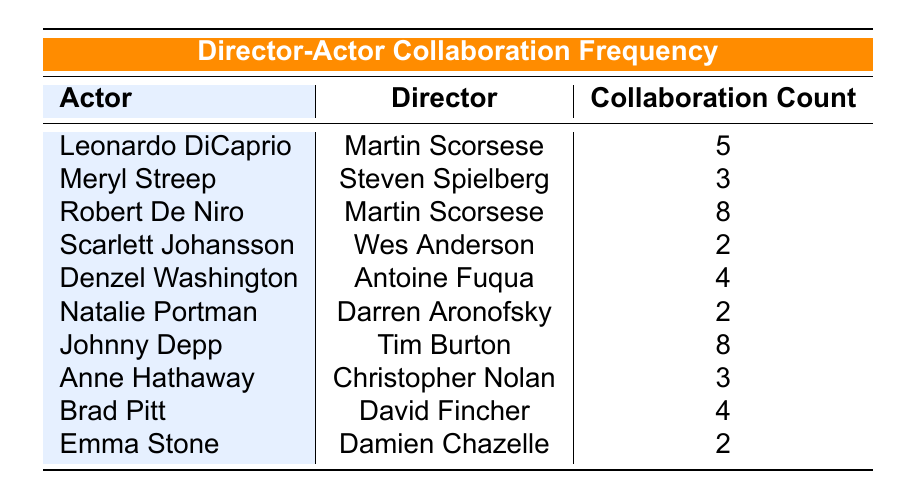What is the highest collaboration count between an actor and a director in the table? The highest collaboration count can be found by looking at the values in the "Collaboration Count" column. The maximum value is 8, which corresponds to Johnny Depp with Tim Burton and Robert De Niro with Martin Scorsese.
Answer: 8 How many collaborations did Robert De Niro have with Martin Scorsese? The table directly lists Robert De Niro's collaboration with Martin Scorsese, which shows a collaboration count of 8.
Answer: 8 Is there any actor who has collaborated with a director more than five times? By reviewing the "Collaboration Count" column, we can see that both Robert De Niro (8) and Johnny Depp (8) have collaborations that exceed five. Hence, the answer is yes.
Answer: Yes What is the average collaboration count for all the actors listed in the table? To find the average, sum all the collaboration counts: (5 + 3 + 8 + 2 + 4 + 2 + 8 + 3 + 4 + 2) = 41, and divide by the number of actors (10), which gives 41/10 = 4.1.
Answer: 4.1 Did any actor collaborate with more than one director? From the table, it appears that each actor is paired with only one director each. Hence, no actor is shown collaborating with multiple directors.
Answer: No How many actors collaborated with their respective directors at least twice? By checking the "Collaboration Count" column, we can see that all actors except Scarlett Johansson, Natalie Portman, and Emma Stone have collaboration counts of 2 or more, totaling 7 actors.
Answer: 7 What is the difference in collaboration counts between the highest (8) and the lowest (2) in the table? The highest collaboration count is 8 (Robert De Niro with Martin Scorsese or Johnny Depp with Tim Burton) and the lowest is 2 (Scarlett Johansson with Wes Anderson, Natalie Portman with Darren Aronofsky, or Emma Stone with Damien Chazelle). The difference is calculated as 8 - 2 = 6.
Answer: 6 Which director has the most collaborations listed in the table? To determine this, we compare the number of collaborations each director has with their respective actors. Martin Scorsese (2 actors) and Tim Burton (1 actor) are the directors with the most collaborations, resulting in a tie.
Answer: Martin Scorsese and Tim Burton How many actors collaborated with directors that have a collaboration count of exactly 2? The actors with a collaboration count of 2 are Scarlett Johansson, Natalie Portman, and Emma Stone. Therefore, there are 3 actors collaborating with directors with exactly 2 collaborations.
Answer: 3 